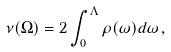<formula> <loc_0><loc_0><loc_500><loc_500>\nu ( \Omega ) = 2 \int _ { 0 } ^ { \Lambda } \rho ( \omega ) d \omega \, ,</formula> 